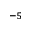Convert formula to latex. <formula><loc_0><loc_0><loc_500><loc_500>^ { - 5 }</formula> 